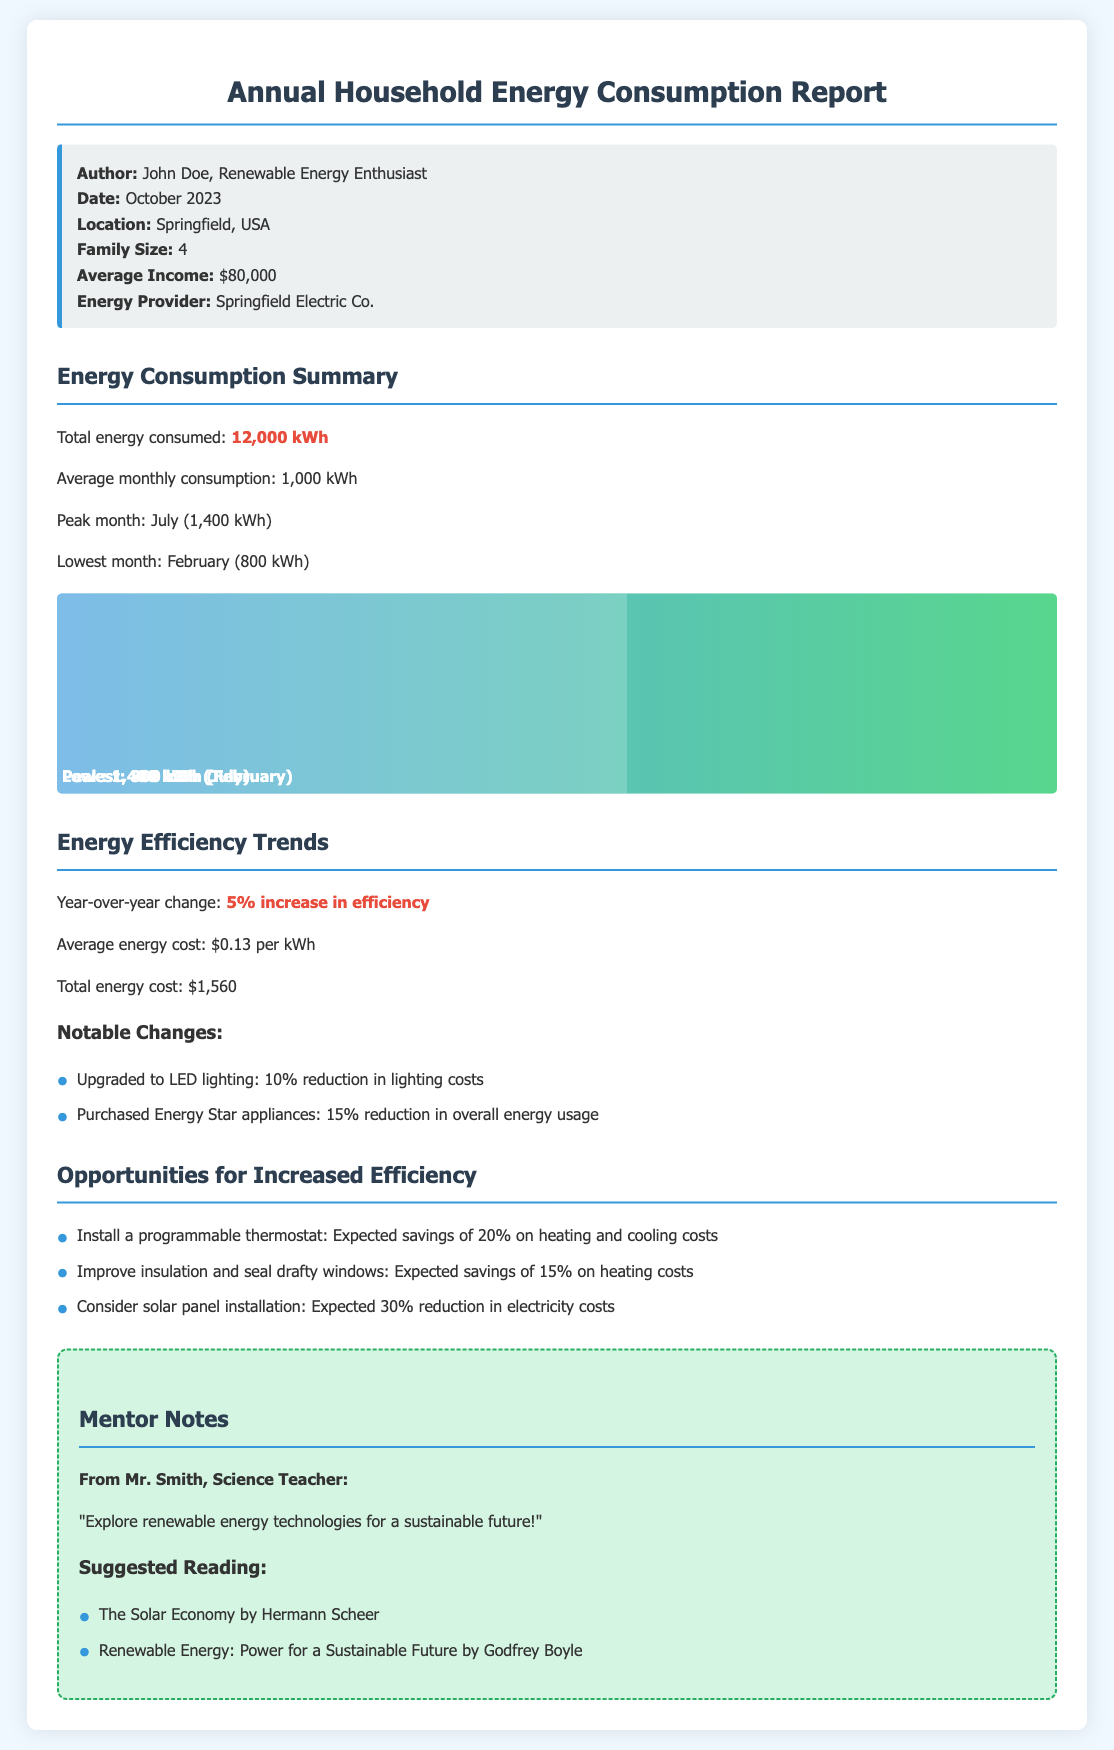What is the total energy consumed? The total energy consumed is explicitly stated in the report.
Answer: 12,000 kWh What was the peak month for energy consumption? The report highlights the peak month and the corresponding energy usage.
Answer: July What is the average monthly energy cost? The document mentions the average energy cost per kWh.
Answer: $0.13 per kWh What is the expected savings from installing a programmable thermostat? The report outlines specific opportunities for increased efficiency and their expected savings.
Answer: 20% What was the year-over-year change in energy efficiency? This information reflects the trend in energy efficiency mentioned in the report.
Answer: 5% increase in efficiency Which month had the lowest energy consumption? The report specifies the month with the lowest recorded energy consumption.
Answer: February What appliances contributed to a 15% reduction in overall energy usage? The document specifically mentions the type of appliances that led to the energy reduction.
Answer: Energy Star appliances What is the expected savings from improving insulation and sealing drafty windows? The document lists the expected savings for this efficiency opportunity.
Answer: 15% on heating costs Who authored the report? The report identifies the author clearly in the information box.
Answer: John Doe 